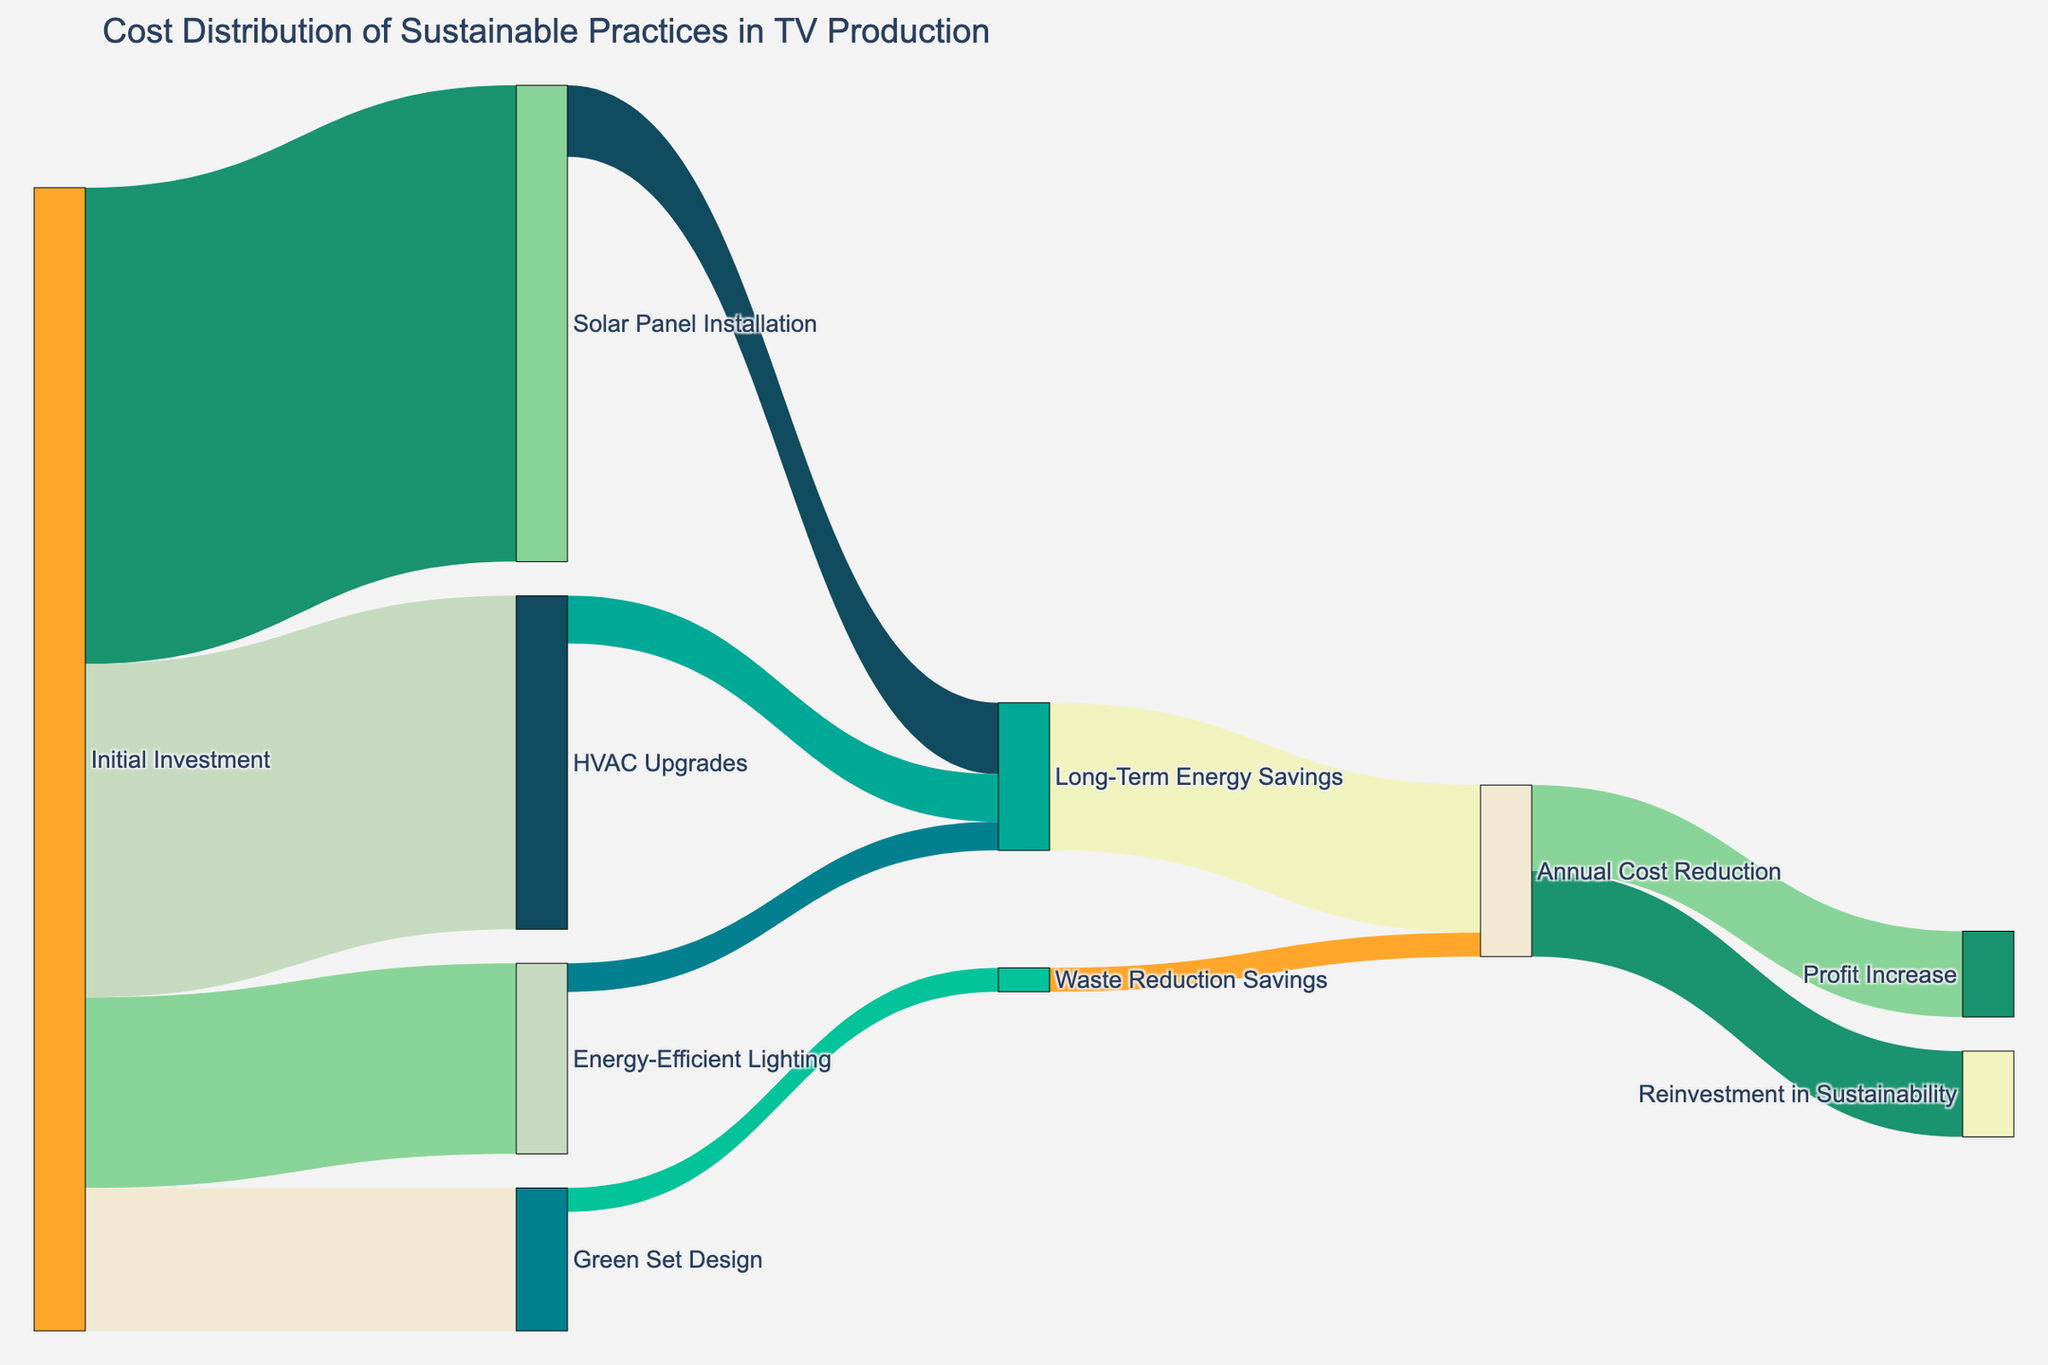What is the largest initial investment category? Refer to the figure to compare the values of all the initial investment categories. Solar Panel Installation shows the highest investment of 500,000.
Answer: Solar Panel Installation What is the total amount allocated to Initial Investment? Add up the values of all initial investment categories (500,000 for Solar Panel Installation, 200,000 for Energy-Efficient Lighting, 350,000 for HVAC Upgrades, and 150,000 for Green Set Design). This totals to 1,200,000.
Answer: 1,200,000 How much in total is attributed to Long-Term Energy Savings? Sum the Long-Term Energy Savings from all contributing sources (75,000 from Solar Panel Installation, 30,000 from Energy-Efficient Lighting, and 50,000 from HVAC Upgrades). This totals to 155,000.
Answer: 155,000 Which category contributes more to Annual Cost Reduction: Long-Term Energy Savings or Waste Reduction Savings? Compare the values contributing to Annual Cost Reduction from Long-Term Energy Savings (155,000) and Waste Reduction Savings (25,000). Long-Term Energy Savings has a higher contribution.
Answer: Long-Term Energy Savings What is the total reinvested in sustainability and profit increase from Annual Cost Reduction? Add the value allocated to Reinvestment in Sustainability and Profit Increase (90,000 each). This totals to 180,000.
Answer: 180,000 How much do Green Set Design savings contribute to Waste Reduction Savings? Observe the figure where Green Set Design directly links to Waste Reduction Savings with a value of 25,000.
Answer: 25,000 How much more is the Long-Term Energy Savings from HVAC Upgrades compared to Energy-Efficient Lighting? Subtract the value of Energy-Efficient Lighting’s Long-Term Energy Savings (30,000) from HVAC Upgrades' Long-Term Energy Savings (50,000). The difference is 20,000.
Answer: 20,000 In terms of initial costs, how does Energy-Efficient Lighting compare to Green Set Design? Compare the initial investments for Energy-Efficient Lighting (200,000) and Green Set Design (150,000). Energy-Efficient Lighting has a higher initial cost by 50,000.
Answer: 50,000 Which category provides the lowest Long-Term Energy Savings? Compare the Long-Term Energy Savings for Solar Panel Installation (75,000), Energy-Efficient Lighting (30,000), and HVAC Upgrades (50,000). Energy-Efficient Lighting contributes the least with 30,000.
Answer: Energy-Efficient Lighting How are the savings from Waste Reduction distributed? The figure shows a single link from Waste Reduction Savings worth 25,000 directed toward Annual Cost Reduction.
Answer: Annual Cost Reduction 